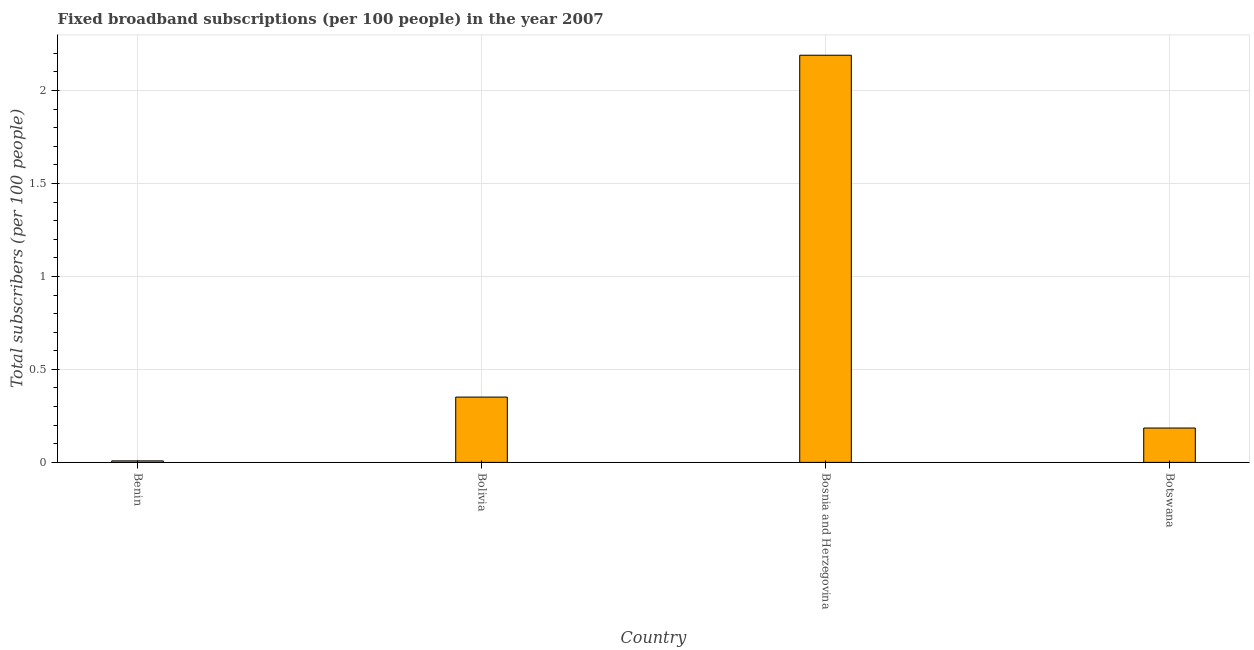Does the graph contain any zero values?
Keep it short and to the point. No. Does the graph contain grids?
Ensure brevity in your answer.  Yes. What is the title of the graph?
Offer a very short reply. Fixed broadband subscriptions (per 100 people) in the year 2007. What is the label or title of the Y-axis?
Provide a short and direct response. Total subscribers (per 100 people). What is the total number of fixed broadband subscriptions in Bosnia and Herzegovina?
Offer a terse response. 2.19. Across all countries, what is the maximum total number of fixed broadband subscriptions?
Make the answer very short. 2.19. Across all countries, what is the minimum total number of fixed broadband subscriptions?
Make the answer very short. 0.01. In which country was the total number of fixed broadband subscriptions maximum?
Ensure brevity in your answer.  Bosnia and Herzegovina. In which country was the total number of fixed broadband subscriptions minimum?
Give a very brief answer. Benin. What is the sum of the total number of fixed broadband subscriptions?
Offer a terse response. 2.73. What is the difference between the total number of fixed broadband subscriptions in Benin and Bolivia?
Provide a succinct answer. -0.34. What is the average total number of fixed broadband subscriptions per country?
Give a very brief answer. 0.68. What is the median total number of fixed broadband subscriptions?
Offer a very short reply. 0.27. What is the ratio of the total number of fixed broadband subscriptions in Bolivia to that in Botswana?
Your response must be concise. 1.9. Is the total number of fixed broadband subscriptions in Bosnia and Herzegovina less than that in Botswana?
Make the answer very short. No. Is the difference between the total number of fixed broadband subscriptions in Benin and Botswana greater than the difference between any two countries?
Make the answer very short. No. What is the difference between the highest and the second highest total number of fixed broadband subscriptions?
Your answer should be compact. 1.84. What is the difference between the highest and the lowest total number of fixed broadband subscriptions?
Your answer should be very brief. 2.18. In how many countries, is the total number of fixed broadband subscriptions greater than the average total number of fixed broadband subscriptions taken over all countries?
Provide a succinct answer. 1. How many bars are there?
Keep it short and to the point. 4. Are all the bars in the graph horizontal?
Your answer should be very brief. No. What is the Total subscribers (per 100 people) of Benin?
Provide a succinct answer. 0.01. What is the Total subscribers (per 100 people) in Bolivia?
Provide a short and direct response. 0.35. What is the Total subscribers (per 100 people) in Bosnia and Herzegovina?
Your response must be concise. 2.19. What is the Total subscribers (per 100 people) in Botswana?
Your response must be concise. 0.18. What is the difference between the Total subscribers (per 100 people) in Benin and Bolivia?
Keep it short and to the point. -0.34. What is the difference between the Total subscribers (per 100 people) in Benin and Bosnia and Herzegovina?
Your answer should be compact. -2.18. What is the difference between the Total subscribers (per 100 people) in Benin and Botswana?
Offer a terse response. -0.18. What is the difference between the Total subscribers (per 100 people) in Bolivia and Bosnia and Herzegovina?
Provide a short and direct response. -1.84. What is the difference between the Total subscribers (per 100 people) in Bolivia and Botswana?
Your response must be concise. 0.17. What is the difference between the Total subscribers (per 100 people) in Bosnia and Herzegovina and Botswana?
Provide a short and direct response. 2. What is the ratio of the Total subscribers (per 100 people) in Benin to that in Bolivia?
Offer a terse response. 0.02. What is the ratio of the Total subscribers (per 100 people) in Benin to that in Bosnia and Herzegovina?
Provide a short and direct response. 0. What is the ratio of the Total subscribers (per 100 people) in Benin to that in Botswana?
Give a very brief answer. 0.04. What is the ratio of the Total subscribers (per 100 people) in Bolivia to that in Bosnia and Herzegovina?
Provide a short and direct response. 0.16. What is the ratio of the Total subscribers (per 100 people) in Bolivia to that in Botswana?
Ensure brevity in your answer.  1.9. What is the ratio of the Total subscribers (per 100 people) in Bosnia and Herzegovina to that in Botswana?
Your answer should be very brief. 11.84. 